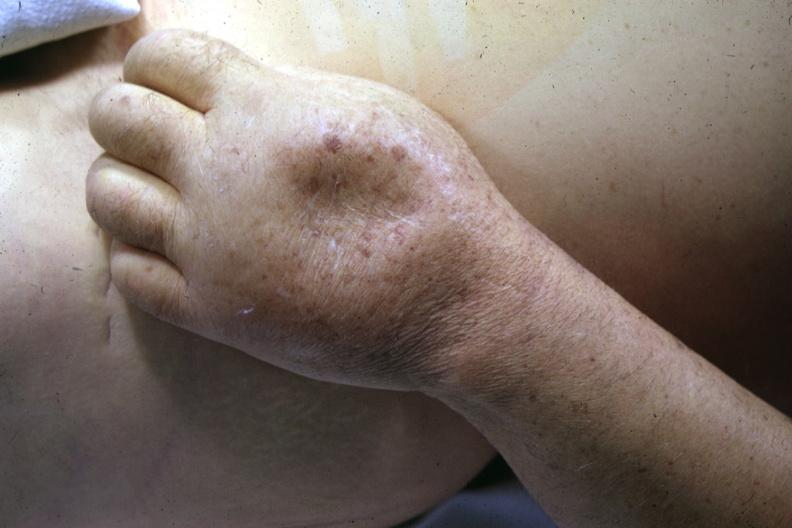what does this image show?
Answer the question using a single word or phrase. Close-up of dorsum of hand with marked pitting edema good example 